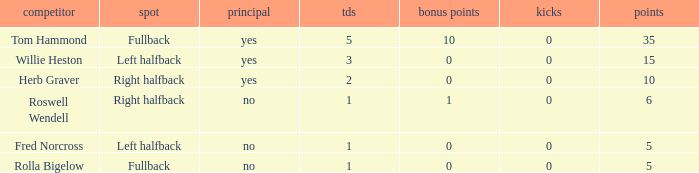How many extra points did right halfback Roswell Wendell have? 1.0. 